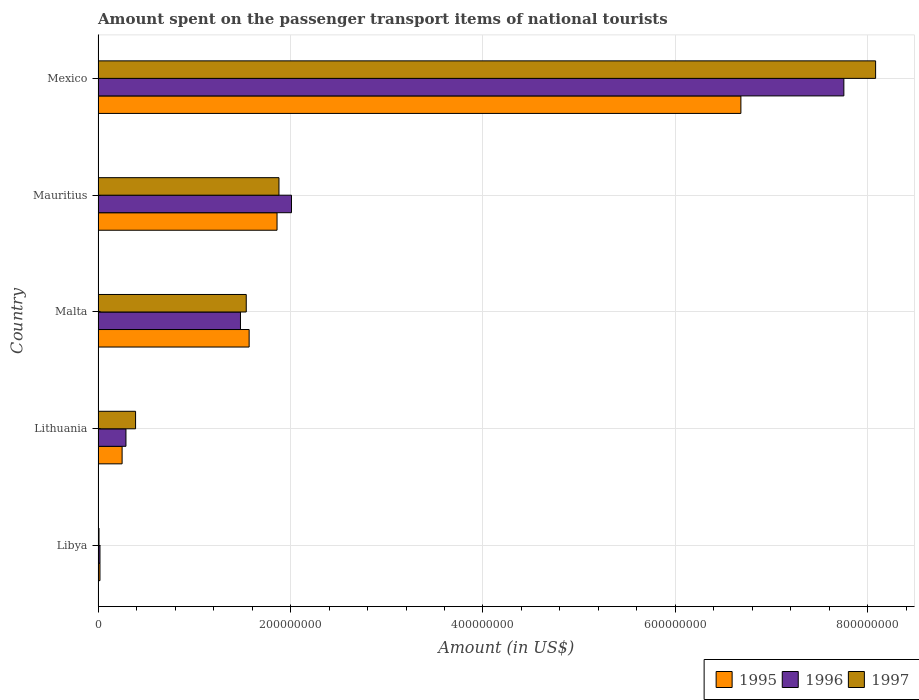How many different coloured bars are there?
Provide a succinct answer. 3. How many groups of bars are there?
Your answer should be compact. 5. Are the number of bars per tick equal to the number of legend labels?
Keep it short and to the point. Yes. Are the number of bars on each tick of the Y-axis equal?
Your answer should be compact. Yes. How many bars are there on the 2nd tick from the top?
Make the answer very short. 3. How many bars are there on the 5th tick from the bottom?
Your answer should be compact. 3. What is the label of the 4th group of bars from the top?
Keep it short and to the point. Lithuania. In how many cases, is the number of bars for a given country not equal to the number of legend labels?
Keep it short and to the point. 0. Across all countries, what is the maximum amount spent on the passenger transport items of national tourists in 1997?
Ensure brevity in your answer.  8.08e+08. In which country was the amount spent on the passenger transport items of national tourists in 1996 minimum?
Keep it short and to the point. Libya. What is the total amount spent on the passenger transport items of national tourists in 1995 in the graph?
Give a very brief answer. 1.04e+09. What is the difference between the amount spent on the passenger transport items of national tourists in 1996 in Libya and that in Mauritius?
Offer a very short reply. -1.99e+08. What is the difference between the amount spent on the passenger transport items of national tourists in 1996 in Mauritius and the amount spent on the passenger transport items of national tourists in 1995 in Libya?
Provide a short and direct response. 1.99e+08. What is the average amount spent on the passenger transport items of national tourists in 1996 per country?
Your answer should be very brief. 2.31e+08. What is the ratio of the amount spent on the passenger transport items of national tourists in 1997 in Libya to that in Malta?
Your response must be concise. 0.01. Is the amount spent on the passenger transport items of national tourists in 1997 in Libya less than that in Mexico?
Make the answer very short. Yes. What is the difference between the highest and the second highest amount spent on the passenger transport items of national tourists in 1997?
Offer a very short reply. 6.20e+08. What is the difference between the highest and the lowest amount spent on the passenger transport items of national tourists in 1995?
Make the answer very short. 6.66e+08. Is the sum of the amount spent on the passenger transport items of national tourists in 1996 in Libya and Malta greater than the maximum amount spent on the passenger transport items of national tourists in 1997 across all countries?
Give a very brief answer. No. What does the 2nd bar from the top in Libya represents?
Make the answer very short. 1996. What does the 3rd bar from the bottom in Mexico represents?
Offer a very short reply. 1997. Is it the case that in every country, the sum of the amount spent on the passenger transport items of national tourists in 1995 and amount spent on the passenger transport items of national tourists in 1996 is greater than the amount spent on the passenger transport items of national tourists in 1997?
Provide a succinct answer. Yes. How many countries are there in the graph?
Give a very brief answer. 5. What is the difference between two consecutive major ticks on the X-axis?
Ensure brevity in your answer.  2.00e+08. How are the legend labels stacked?
Provide a succinct answer. Horizontal. What is the title of the graph?
Give a very brief answer. Amount spent on the passenger transport items of national tourists. Does "1964" appear as one of the legend labels in the graph?
Keep it short and to the point. No. What is the Amount (in US$) of 1995 in Libya?
Provide a succinct answer. 2.00e+06. What is the Amount (in US$) in 1996 in Libya?
Give a very brief answer. 2.00e+06. What is the Amount (in US$) in 1995 in Lithuania?
Offer a very short reply. 2.50e+07. What is the Amount (in US$) of 1996 in Lithuania?
Provide a succinct answer. 2.90e+07. What is the Amount (in US$) in 1997 in Lithuania?
Keep it short and to the point. 3.90e+07. What is the Amount (in US$) of 1995 in Malta?
Provide a short and direct response. 1.57e+08. What is the Amount (in US$) of 1996 in Malta?
Make the answer very short. 1.48e+08. What is the Amount (in US$) of 1997 in Malta?
Your answer should be compact. 1.54e+08. What is the Amount (in US$) of 1995 in Mauritius?
Provide a short and direct response. 1.86e+08. What is the Amount (in US$) of 1996 in Mauritius?
Your answer should be compact. 2.01e+08. What is the Amount (in US$) in 1997 in Mauritius?
Your answer should be compact. 1.88e+08. What is the Amount (in US$) in 1995 in Mexico?
Ensure brevity in your answer.  6.68e+08. What is the Amount (in US$) of 1996 in Mexico?
Make the answer very short. 7.75e+08. What is the Amount (in US$) of 1997 in Mexico?
Offer a terse response. 8.08e+08. Across all countries, what is the maximum Amount (in US$) of 1995?
Offer a terse response. 6.68e+08. Across all countries, what is the maximum Amount (in US$) in 1996?
Offer a terse response. 7.75e+08. Across all countries, what is the maximum Amount (in US$) in 1997?
Your response must be concise. 8.08e+08. Across all countries, what is the minimum Amount (in US$) in 1996?
Your response must be concise. 2.00e+06. What is the total Amount (in US$) in 1995 in the graph?
Offer a terse response. 1.04e+09. What is the total Amount (in US$) of 1996 in the graph?
Provide a short and direct response. 1.16e+09. What is the total Amount (in US$) in 1997 in the graph?
Ensure brevity in your answer.  1.19e+09. What is the difference between the Amount (in US$) in 1995 in Libya and that in Lithuania?
Offer a terse response. -2.30e+07. What is the difference between the Amount (in US$) of 1996 in Libya and that in Lithuania?
Your answer should be compact. -2.70e+07. What is the difference between the Amount (in US$) in 1997 in Libya and that in Lithuania?
Keep it short and to the point. -3.80e+07. What is the difference between the Amount (in US$) in 1995 in Libya and that in Malta?
Provide a short and direct response. -1.55e+08. What is the difference between the Amount (in US$) of 1996 in Libya and that in Malta?
Offer a very short reply. -1.46e+08. What is the difference between the Amount (in US$) in 1997 in Libya and that in Malta?
Your response must be concise. -1.53e+08. What is the difference between the Amount (in US$) in 1995 in Libya and that in Mauritius?
Ensure brevity in your answer.  -1.84e+08. What is the difference between the Amount (in US$) in 1996 in Libya and that in Mauritius?
Give a very brief answer. -1.99e+08. What is the difference between the Amount (in US$) in 1997 in Libya and that in Mauritius?
Provide a short and direct response. -1.87e+08. What is the difference between the Amount (in US$) of 1995 in Libya and that in Mexico?
Keep it short and to the point. -6.66e+08. What is the difference between the Amount (in US$) of 1996 in Libya and that in Mexico?
Provide a succinct answer. -7.73e+08. What is the difference between the Amount (in US$) in 1997 in Libya and that in Mexico?
Make the answer very short. -8.07e+08. What is the difference between the Amount (in US$) in 1995 in Lithuania and that in Malta?
Provide a succinct answer. -1.32e+08. What is the difference between the Amount (in US$) in 1996 in Lithuania and that in Malta?
Your answer should be compact. -1.19e+08. What is the difference between the Amount (in US$) of 1997 in Lithuania and that in Malta?
Offer a very short reply. -1.15e+08. What is the difference between the Amount (in US$) in 1995 in Lithuania and that in Mauritius?
Your answer should be very brief. -1.61e+08. What is the difference between the Amount (in US$) in 1996 in Lithuania and that in Mauritius?
Keep it short and to the point. -1.72e+08. What is the difference between the Amount (in US$) in 1997 in Lithuania and that in Mauritius?
Provide a succinct answer. -1.49e+08. What is the difference between the Amount (in US$) in 1995 in Lithuania and that in Mexico?
Provide a short and direct response. -6.43e+08. What is the difference between the Amount (in US$) of 1996 in Lithuania and that in Mexico?
Keep it short and to the point. -7.46e+08. What is the difference between the Amount (in US$) of 1997 in Lithuania and that in Mexico?
Your answer should be compact. -7.69e+08. What is the difference between the Amount (in US$) in 1995 in Malta and that in Mauritius?
Provide a short and direct response. -2.90e+07. What is the difference between the Amount (in US$) in 1996 in Malta and that in Mauritius?
Offer a very short reply. -5.30e+07. What is the difference between the Amount (in US$) of 1997 in Malta and that in Mauritius?
Your answer should be very brief. -3.40e+07. What is the difference between the Amount (in US$) in 1995 in Malta and that in Mexico?
Provide a short and direct response. -5.11e+08. What is the difference between the Amount (in US$) of 1996 in Malta and that in Mexico?
Ensure brevity in your answer.  -6.27e+08. What is the difference between the Amount (in US$) in 1997 in Malta and that in Mexico?
Keep it short and to the point. -6.54e+08. What is the difference between the Amount (in US$) in 1995 in Mauritius and that in Mexico?
Make the answer very short. -4.82e+08. What is the difference between the Amount (in US$) in 1996 in Mauritius and that in Mexico?
Give a very brief answer. -5.74e+08. What is the difference between the Amount (in US$) in 1997 in Mauritius and that in Mexico?
Offer a very short reply. -6.20e+08. What is the difference between the Amount (in US$) of 1995 in Libya and the Amount (in US$) of 1996 in Lithuania?
Your answer should be very brief. -2.70e+07. What is the difference between the Amount (in US$) in 1995 in Libya and the Amount (in US$) in 1997 in Lithuania?
Your answer should be very brief. -3.70e+07. What is the difference between the Amount (in US$) of 1996 in Libya and the Amount (in US$) of 1997 in Lithuania?
Provide a short and direct response. -3.70e+07. What is the difference between the Amount (in US$) of 1995 in Libya and the Amount (in US$) of 1996 in Malta?
Your answer should be compact. -1.46e+08. What is the difference between the Amount (in US$) in 1995 in Libya and the Amount (in US$) in 1997 in Malta?
Offer a very short reply. -1.52e+08. What is the difference between the Amount (in US$) in 1996 in Libya and the Amount (in US$) in 1997 in Malta?
Offer a terse response. -1.52e+08. What is the difference between the Amount (in US$) of 1995 in Libya and the Amount (in US$) of 1996 in Mauritius?
Make the answer very short. -1.99e+08. What is the difference between the Amount (in US$) in 1995 in Libya and the Amount (in US$) in 1997 in Mauritius?
Provide a short and direct response. -1.86e+08. What is the difference between the Amount (in US$) of 1996 in Libya and the Amount (in US$) of 1997 in Mauritius?
Give a very brief answer. -1.86e+08. What is the difference between the Amount (in US$) in 1995 in Libya and the Amount (in US$) in 1996 in Mexico?
Your answer should be compact. -7.73e+08. What is the difference between the Amount (in US$) in 1995 in Libya and the Amount (in US$) in 1997 in Mexico?
Provide a succinct answer. -8.06e+08. What is the difference between the Amount (in US$) in 1996 in Libya and the Amount (in US$) in 1997 in Mexico?
Ensure brevity in your answer.  -8.06e+08. What is the difference between the Amount (in US$) of 1995 in Lithuania and the Amount (in US$) of 1996 in Malta?
Keep it short and to the point. -1.23e+08. What is the difference between the Amount (in US$) in 1995 in Lithuania and the Amount (in US$) in 1997 in Malta?
Your answer should be very brief. -1.29e+08. What is the difference between the Amount (in US$) of 1996 in Lithuania and the Amount (in US$) of 1997 in Malta?
Provide a short and direct response. -1.25e+08. What is the difference between the Amount (in US$) of 1995 in Lithuania and the Amount (in US$) of 1996 in Mauritius?
Your answer should be very brief. -1.76e+08. What is the difference between the Amount (in US$) of 1995 in Lithuania and the Amount (in US$) of 1997 in Mauritius?
Provide a succinct answer. -1.63e+08. What is the difference between the Amount (in US$) in 1996 in Lithuania and the Amount (in US$) in 1997 in Mauritius?
Offer a very short reply. -1.59e+08. What is the difference between the Amount (in US$) in 1995 in Lithuania and the Amount (in US$) in 1996 in Mexico?
Keep it short and to the point. -7.50e+08. What is the difference between the Amount (in US$) of 1995 in Lithuania and the Amount (in US$) of 1997 in Mexico?
Your answer should be very brief. -7.83e+08. What is the difference between the Amount (in US$) in 1996 in Lithuania and the Amount (in US$) in 1997 in Mexico?
Your response must be concise. -7.79e+08. What is the difference between the Amount (in US$) in 1995 in Malta and the Amount (in US$) in 1996 in Mauritius?
Your answer should be very brief. -4.40e+07. What is the difference between the Amount (in US$) in 1995 in Malta and the Amount (in US$) in 1997 in Mauritius?
Provide a short and direct response. -3.10e+07. What is the difference between the Amount (in US$) in 1996 in Malta and the Amount (in US$) in 1997 in Mauritius?
Provide a short and direct response. -4.00e+07. What is the difference between the Amount (in US$) in 1995 in Malta and the Amount (in US$) in 1996 in Mexico?
Make the answer very short. -6.18e+08. What is the difference between the Amount (in US$) in 1995 in Malta and the Amount (in US$) in 1997 in Mexico?
Offer a very short reply. -6.51e+08. What is the difference between the Amount (in US$) in 1996 in Malta and the Amount (in US$) in 1997 in Mexico?
Ensure brevity in your answer.  -6.60e+08. What is the difference between the Amount (in US$) in 1995 in Mauritius and the Amount (in US$) in 1996 in Mexico?
Ensure brevity in your answer.  -5.89e+08. What is the difference between the Amount (in US$) of 1995 in Mauritius and the Amount (in US$) of 1997 in Mexico?
Ensure brevity in your answer.  -6.22e+08. What is the difference between the Amount (in US$) of 1996 in Mauritius and the Amount (in US$) of 1997 in Mexico?
Your response must be concise. -6.07e+08. What is the average Amount (in US$) of 1995 per country?
Offer a very short reply. 2.08e+08. What is the average Amount (in US$) in 1996 per country?
Your answer should be compact. 2.31e+08. What is the average Amount (in US$) of 1997 per country?
Keep it short and to the point. 2.38e+08. What is the difference between the Amount (in US$) of 1995 and Amount (in US$) of 1996 in Libya?
Offer a very short reply. 0. What is the difference between the Amount (in US$) of 1995 and Amount (in US$) of 1997 in Lithuania?
Provide a short and direct response. -1.40e+07. What is the difference between the Amount (in US$) in 1996 and Amount (in US$) in 1997 in Lithuania?
Offer a very short reply. -1.00e+07. What is the difference between the Amount (in US$) of 1995 and Amount (in US$) of 1996 in Malta?
Provide a short and direct response. 9.00e+06. What is the difference between the Amount (in US$) in 1995 and Amount (in US$) in 1997 in Malta?
Your answer should be compact. 3.00e+06. What is the difference between the Amount (in US$) of 1996 and Amount (in US$) of 1997 in Malta?
Offer a very short reply. -6.00e+06. What is the difference between the Amount (in US$) of 1995 and Amount (in US$) of 1996 in Mauritius?
Offer a terse response. -1.50e+07. What is the difference between the Amount (in US$) in 1995 and Amount (in US$) in 1997 in Mauritius?
Ensure brevity in your answer.  -2.00e+06. What is the difference between the Amount (in US$) in 1996 and Amount (in US$) in 1997 in Mauritius?
Provide a short and direct response. 1.30e+07. What is the difference between the Amount (in US$) in 1995 and Amount (in US$) in 1996 in Mexico?
Provide a succinct answer. -1.07e+08. What is the difference between the Amount (in US$) of 1995 and Amount (in US$) of 1997 in Mexico?
Ensure brevity in your answer.  -1.40e+08. What is the difference between the Amount (in US$) of 1996 and Amount (in US$) of 1997 in Mexico?
Ensure brevity in your answer.  -3.30e+07. What is the ratio of the Amount (in US$) in 1995 in Libya to that in Lithuania?
Give a very brief answer. 0.08. What is the ratio of the Amount (in US$) of 1996 in Libya to that in Lithuania?
Give a very brief answer. 0.07. What is the ratio of the Amount (in US$) of 1997 in Libya to that in Lithuania?
Offer a very short reply. 0.03. What is the ratio of the Amount (in US$) in 1995 in Libya to that in Malta?
Offer a terse response. 0.01. What is the ratio of the Amount (in US$) in 1996 in Libya to that in Malta?
Offer a terse response. 0.01. What is the ratio of the Amount (in US$) of 1997 in Libya to that in Malta?
Keep it short and to the point. 0.01. What is the ratio of the Amount (in US$) in 1995 in Libya to that in Mauritius?
Your answer should be very brief. 0.01. What is the ratio of the Amount (in US$) in 1997 in Libya to that in Mauritius?
Provide a short and direct response. 0.01. What is the ratio of the Amount (in US$) in 1995 in Libya to that in Mexico?
Offer a terse response. 0. What is the ratio of the Amount (in US$) of 1996 in Libya to that in Mexico?
Offer a very short reply. 0. What is the ratio of the Amount (in US$) of 1997 in Libya to that in Mexico?
Provide a short and direct response. 0. What is the ratio of the Amount (in US$) in 1995 in Lithuania to that in Malta?
Give a very brief answer. 0.16. What is the ratio of the Amount (in US$) of 1996 in Lithuania to that in Malta?
Provide a short and direct response. 0.2. What is the ratio of the Amount (in US$) of 1997 in Lithuania to that in Malta?
Give a very brief answer. 0.25. What is the ratio of the Amount (in US$) of 1995 in Lithuania to that in Mauritius?
Provide a short and direct response. 0.13. What is the ratio of the Amount (in US$) of 1996 in Lithuania to that in Mauritius?
Give a very brief answer. 0.14. What is the ratio of the Amount (in US$) of 1997 in Lithuania to that in Mauritius?
Your answer should be very brief. 0.21. What is the ratio of the Amount (in US$) of 1995 in Lithuania to that in Mexico?
Your answer should be compact. 0.04. What is the ratio of the Amount (in US$) in 1996 in Lithuania to that in Mexico?
Provide a succinct answer. 0.04. What is the ratio of the Amount (in US$) in 1997 in Lithuania to that in Mexico?
Your answer should be compact. 0.05. What is the ratio of the Amount (in US$) in 1995 in Malta to that in Mauritius?
Your response must be concise. 0.84. What is the ratio of the Amount (in US$) of 1996 in Malta to that in Mauritius?
Give a very brief answer. 0.74. What is the ratio of the Amount (in US$) in 1997 in Malta to that in Mauritius?
Give a very brief answer. 0.82. What is the ratio of the Amount (in US$) in 1995 in Malta to that in Mexico?
Offer a very short reply. 0.23. What is the ratio of the Amount (in US$) in 1996 in Malta to that in Mexico?
Your answer should be very brief. 0.19. What is the ratio of the Amount (in US$) of 1997 in Malta to that in Mexico?
Your answer should be very brief. 0.19. What is the ratio of the Amount (in US$) in 1995 in Mauritius to that in Mexico?
Ensure brevity in your answer.  0.28. What is the ratio of the Amount (in US$) in 1996 in Mauritius to that in Mexico?
Give a very brief answer. 0.26. What is the ratio of the Amount (in US$) in 1997 in Mauritius to that in Mexico?
Your response must be concise. 0.23. What is the difference between the highest and the second highest Amount (in US$) in 1995?
Offer a very short reply. 4.82e+08. What is the difference between the highest and the second highest Amount (in US$) in 1996?
Give a very brief answer. 5.74e+08. What is the difference between the highest and the second highest Amount (in US$) of 1997?
Keep it short and to the point. 6.20e+08. What is the difference between the highest and the lowest Amount (in US$) in 1995?
Provide a short and direct response. 6.66e+08. What is the difference between the highest and the lowest Amount (in US$) in 1996?
Your answer should be compact. 7.73e+08. What is the difference between the highest and the lowest Amount (in US$) in 1997?
Your response must be concise. 8.07e+08. 